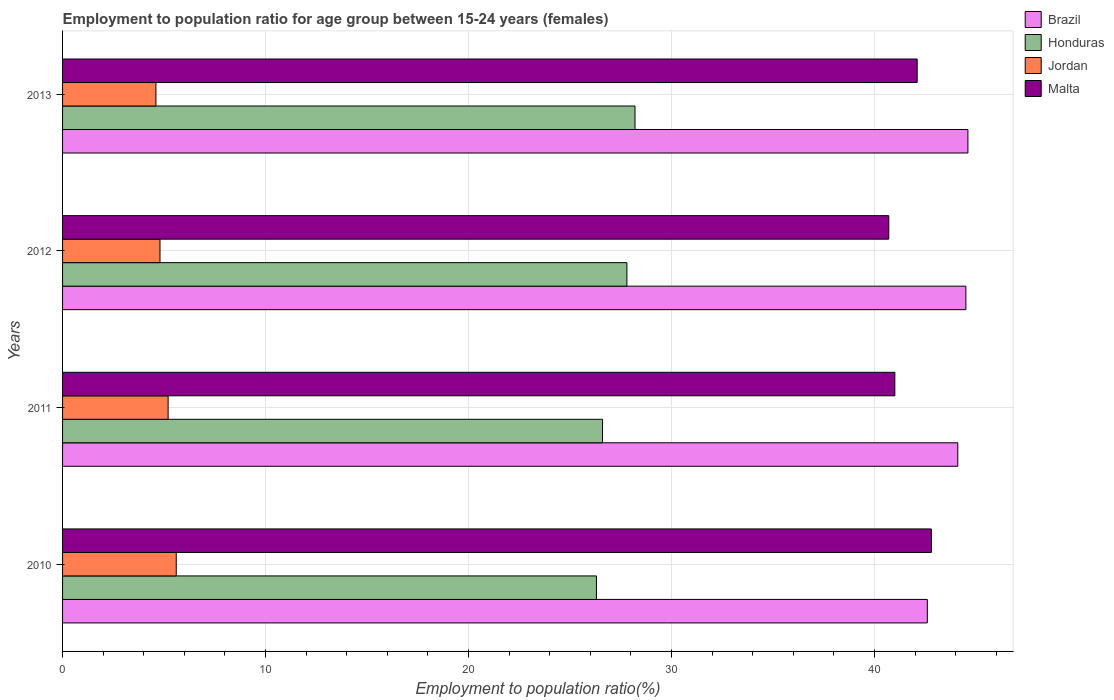How many different coloured bars are there?
Offer a terse response. 4. How many bars are there on the 1st tick from the top?
Ensure brevity in your answer.  4. What is the employment to population ratio in Malta in 2010?
Make the answer very short. 42.8. Across all years, what is the maximum employment to population ratio in Brazil?
Offer a very short reply. 44.6. Across all years, what is the minimum employment to population ratio in Honduras?
Your response must be concise. 26.3. In which year was the employment to population ratio in Honduras maximum?
Make the answer very short. 2013. In which year was the employment to population ratio in Malta minimum?
Provide a short and direct response. 2012. What is the total employment to population ratio in Jordan in the graph?
Give a very brief answer. 20.2. What is the difference between the employment to population ratio in Malta in 2010 and that in 2013?
Make the answer very short. 0.7. What is the difference between the employment to population ratio in Brazil in 2011 and the employment to population ratio in Honduras in 2012?
Provide a succinct answer. 16.3. What is the average employment to population ratio in Honduras per year?
Provide a succinct answer. 27.22. In the year 2010, what is the difference between the employment to population ratio in Brazil and employment to population ratio in Malta?
Your response must be concise. -0.2. In how many years, is the employment to population ratio in Brazil greater than 20 %?
Keep it short and to the point. 4. What is the ratio of the employment to population ratio in Brazil in 2010 to that in 2011?
Give a very brief answer. 0.97. What is the difference between the highest and the second highest employment to population ratio in Brazil?
Ensure brevity in your answer.  0.1. What is the difference between the highest and the lowest employment to population ratio in Malta?
Offer a terse response. 2.1. In how many years, is the employment to population ratio in Honduras greater than the average employment to population ratio in Honduras taken over all years?
Your response must be concise. 2. Is the sum of the employment to population ratio in Malta in 2011 and 2012 greater than the maximum employment to population ratio in Jordan across all years?
Your answer should be compact. Yes. Is it the case that in every year, the sum of the employment to population ratio in Malta and employment to population ratio in Honduras is greater than the sum of employment to population ratio in Jordan and employment to population ratio in Brazil?
Ensure brevity in your answer.  No. What does the 2nd bar from the top in 2013 represents?
Keep it short and to the point. Jordan. What does the 2nd bar from the bottom in 2013 represents?
Your answer should be compact. Honduras. What is the difference between two consecutive major ticks on the X-axis?
Provide a succinct answer. 10. Does the graph contain any zero values?
Offer a terse response. No. Where does the legend appear in the graph?
Your response must be concise. Top right. What is the title of the graph?
Give a very brief answer. Employment to population ratio for age group between 15-24 years (females). What is the label or title of the X-axis?
Provide a short and direct response. Employment to population ratio(%). What is the label or title of the Y-axis?
Offer a very short reply. Years. What is the Employment to population ratio(%) of Brazil in 2010?
Your answer should be very brief. 42.6. What is the Employment to population ratio(%) of Honduras in 2010?
Your answer should be compact. 26.3. What is the Employment to population ratio(%) of Jordan in 2010?
Your response must be concise. 5.6. What is the Employment to population ratio(%) of Malta in 2010?
Make the answer very short. 42.8. What is the Employment to population ratio(%) in Brazil in 2011?
Provide a succinct answer. 44.1. What is the Employment to population ratio(%) in Honduras in 2011?
Your answer should be compact. 26.6. What is the Employment to population ratio(%) in Jordan in 2011?
Provide a succinct answer. 5.2. What is the Employment to population ratio(%) of Brazil in 2012?
Provide a succinct answer. 44.5. What is the Employment to population ratio(%) of Honduras in 2012?
Your answer should be very brief. 27.8. What is the Employment to population ratio(%) in Jordan in 2012?
Make the answer very short. 4.8. What is the Employment to population ratio(%) in Malta in 2012?
Offer a terse response. 40.7. What is the Employment to population ratio(%) of Brazil in 2013?
Provide a succinct answer. 44.6. What is the Employment to population ratio(%) of Honduras in 2013?
Offer a very short reply. 28.2. What is the Employment to population ratio(%) in Jordan in 2013?
Your answer should be very brief. 4.6. What is the Employment to population ratio(%) in Malta in 2013?
Give a very brief answer. 42.1. Across all years, what is the maximum Employment to population ratio(%) in Brazil?
Offer a very short reply. 44.6. Across all years, what is the maximum Employment to population ratio(%) of Honduras?
Give a very brief answer. 28.2. Across all years, what is the maximum Employment to population ratio(%) in Jordan?
Your answer should be very brief. 5.6. Across all years, what is the maximum Employment to population ratio(%) of Malta?
Your answer should be compact. 42.8. Across all years, what is the minimum Employment to population ratio(%) of Brazil?
Your answer should be very brief. 42.6. Across all years, what is the minimum Employment to population ratio(%) of Honduras?
Provide a succinct answer. 26.3. Across all years, what is the minimum Employment to population ratio(%) in Jordan?
Provide a short and direct response. 4.6. Across all years, what is the minimum Employment to population ratio(%) in Malta?
Offer a very short reply. 40.7. What is the total Employment to population ratio(%) of Brazil in the graph?
Ensure brevity in your answer.  175.8. What is the total Employment to population ratio(%) of Honduras in the graph?
Provide a succinct answer. 108.9. What is the total Employment to population ratio(%) in Jordan in the graph?
Keep it short and to the point. 20.2. What is the total Employment to population ratio(%) in Malta in the graph?
Provide a short and direct response. 166.6. What is the difference between the Employment to population ratio(%) of Honduras in 2010 and that in 2011?
Provide a short and direct response. -0.3. What is the difference between the Employment to population ratio(%) in Jordan in 2010 and that in 2011?
Your answer should be compact. 0.4. What is the difference between the Employment to population ratio(%) in Malta in 2010 and that in 2011?
Your response must be concise. 1.8. What is the difference between the Employment to population ratio(%) in Brazil in 2010 and that in 2012?
Offer a terse response. -1.9. What is the difference between the Employment to population ratio(%) in Honduras in 2010 and that in 2012?
Your answer should be compact. -1.5. What is the difference between the Employment to population ratio(%) in Jordan in 2010 and that in 2012?
Make the answer very short. 0.8. What is the difference between the Employment to population ratio(%) in Malta in 2010 and that in 2012?
Make the answer very short. 2.1. What is the difference between the Employment to population ratio(%) in Honduras in 2010 and that in 2013?
Offer a very short reply. -1.9. What is the difference between the Employment to population ratio(%) in Malta in 2010 and that in 2013?
Your answer should be very brief. 0.7. What is the difference between the Employment to population ratio(%) of Malta in 2011 and that in 2012?
Give a very brief answer. 0.3. What is the difference between the Employment to population ratio(%) in Brazil in 2011 and that in 2013?
Offer a very short reply. -0.5. What is the difference between the Employment to population ratio(%) of Malta in 2011 and that in 2013?
Make the answer very short. -1.1. What is the difference between the Employment to population ratio(%) of Brazil in 2012 and that in 2013?
Your response must be concise. -0.1. What is the difference between the Employment to population ratio(%) of Honduras in 2012 and that in 2013?
Ensure brevity in your answer.  -0.4. What is the difference between the Employment to population ratio(%) of Jordan in 2012 and that in 2013?
Make the answer very short. 0.2. What is the difference between the Employment to population ratio(%) of Brazil in 2010 and the Employment to population ratio(%) of Honduras in 2011?
Your answer should be very brief. 16. What is the difference between the Employment to population ratio(%) of Brazil in 2010 and the Employment to population ratio(%) of Jordan in 2011?
Give a very brief answer. 37.4. What is the difference between the Employment to population ratio(%) of Brazil in 2010 and the Employment to population ratio(%) of Malta in 2011?
Give a very brief answer. 1.6. What is the difference between the Employment to population ratio(%) in Honduras in 2010 and the Employment to population ratio(%) in Jordan in 2011?
Your answer should be compact. 21.1. What is the difference between the Employment to population ratio(%) in Honduras in 2010 and the Employment to population ratio(%) in Malta in 2011?
Your answer should be very brief. -14.7. What is the difference between the Employment to population ratio(%) in Jordan in 2010 and the Employment to population ratio(%) in Malta in 2011?
Make the answer very short. -35.4. What is the difference between the Employment to population ratio(%) in Brazil in 2010 and the Employment to population ratio(%) in Honduras in 2012?
Your answer should be compact. 14.8. What is the difference between the Employment to population ratio(%) of Brazil in 2010 and the Employment to population ratio(%) of Jordan in 2012?
Provide a short and direct response. 37.8. What is the difference between the Employment to population ratio(%) in Honduras in 2010 and the Employment to population ratio(%) in Jordan in 2012?
Provide a short and direct response. 21.5. What is the difference between the Employment to population ratio(%) in Honduras in 2010 and the Employment to population ratio(%) in Malta in 2012?
Keep it short and to the point. -14.4. What is the difference between the Employment to population ratio(%) in Jordan in 2010 and the Employment to population ratio(%) in Malta in 2012?
Your response must be concise. -35.1. What is the difference between the Employment to population ratio(%) of Brazil in 2010 and the Employment to population ratio(%) of Honduras in 2013?
Ensure brevity in your answer.  14.4. What is the difference between the Employment to population ratio(%) in Brazil in 2010 and the Employment to population ratio(%) in Jordan in 2013?
Ensure brevity in your answer.  38. What is the difference between the Employment to population ratio(%) of Brazil in 2010 and the Employment to population ratio(%) of Malta in 2013?
Your answer should be very brief. 0.5. What is the difference between the Employment to population ratio(%) of Honduras in 2010 and the Employment to population ratio(%) of Jordan in 2013?
Your answer should be compact. 21.7. What is the difference between the Employment to population ratio(%) of Honduras in 2010 and the Employment to population ratio(%) of Malta in 2013?
Provide a succinct answer. -15.8. What is the difference between the Employment to population ratio(%) of Jordan in 2010 and the Employment to population ratio(%) of Malta in 2013?
Offer a terse response. -36.5. What is the difference between the Employment to population ratio(%) in Brazil in 2011 and the Employment to population ratio(%) in Honduras in 2012?
Keep it short and to the point. 16.3. What is the difference between the Employment to population ratio(%) of Brazil in 2011 and the Employment to population ratio(%) of Jordan in 2012?
Ensure brevity in your answer.  39.3. What is the difference between the Employment to population ratio(%) of Honduras in 2011 and the Employment to population ratio(%) of Jordan in 2012?
Keep it short and to the point. 21.8. What is the difference between the Employment to population ratio(%) of Honduras in 2011 and the Employment to population ratio(%) of Malta in 2012?
Make the answer very short. -14.1. What is the difference between the Employment to population ratio(%) of Jordan in 2011 and the Employment to population ratio(%) of Malta in 2012?
Your answer should be compact. -35.5. What is the difference between the Employment to population ratio(%) in Brazil in 2011 and the Employment to population ratio(%) in Jordan in 2013?
Keep it short and to the point. 39.5. What is the difference between the Employment to population ratio(%) in Brazil in 2011 and the Employment to population ratio(%) in Malta in 2013?
Provide a succinct answer. 2. What is the difference between the Employment to population ratio(%) in Honduras in 2011 and the Employment to population ratio(%) in Jordan in 2013?
Your response must be concise. 22. What is the difference between the Employment to population ratio(%) of Honduras in 2011 and the Employment to population ratio(%) of Malta in 2013?
Provide a short and direct response. -15.5. What is the difference between the Employment to population ratio(%) of Jordan in 2011 and the Employment to population ratio(%) of Malta in 2013?
Give a very brief answer. -36.9. What is the difference between the Employment to population ratio(%) of Brazil in 2012 and the Employment to population ratio(%) of Jordan in 2013?
Provide a succinct answer. 39.9. What is the difference between the Employment to population ratio(%) of Honduras in 2012 and the Employment to population ratio(%) of Jordan in 2013?
Make the answer very short. 23.2. What is the difference between the Employment to population ratio(%) in Honduras in 2012 and the Employment to population ratio(%) in Malta in 2013?
Keep it short and to the point. -14.3. What is the difference between the Employment to population ratio(%) in Jordan in 2012 and the Employment to population ratio(%) in Malta in 2013?
Your response must be concise. -37.3. What is the average Employment to population ratio(%) in Brazil per year?
Offer a terse response. 43.95. What is the average Employment to population ratio(%) in Honduras per year?
Your response must be concise. 27.23. What is the average Employment to population ratio(%) in Jordan per year?
Make the answer very short. 5.05. What is the average Employment to population ratio(%) of Malta per year?
Provide a short and direct response. 41.65. In the year 2010, what is the difference between the Employment to population ratio(%) in Brazil and Employment to population ratio(%) in Honduras?
Your response must be concise. 16.3. In the year 2010, what is the difference between the Employment to population ratio(%) in Brazil and Employment to population ratio(%) in Jordan?
Provide a succinct answer. 37. In the year 2010, what is the difference between the Employment to population ratio(%) in Honduras and Employment to population ratio(%) in Jordan?
Provide a succinct answer. 20.7. In the year 2010, what is the difference between the Employment to population ratio(%) in Honduras and Employment to population ratio(%) in Malta?
Offer a terse response. -16.5. In the year 2010, what is the difference between the Employment to population ratio(%) in Jordan and Employment to population ratio(%) in Malta?
Provide a short and direct response. -37.2. In the year 2011, what is the difference between the Employment to population ratio(%) in Brazil and Employment to population ratio(%) in Jordan?
Keep it short and to the point. 38.9. In the year 2011, what is the difference between the Employment to population ratio(%) in Brazil and Employment to population ratio(%) in Malta?
Make the answer very short. 3.1. In the year 2011, what is the difference between the Employment to population ratio(%) in Honduras and Employment to population ratio(%) in Jordan?
Offer a terse response. 21.4. In the year 2011, what is the difference between the Employment to population ratio(%) in Honduras and Employment to population ratio(%) in Malta?
Ensure brevity in your answer.  -14.4. In the year 2011, what is the difference between the Employment to population ratio(%) in Jordan and Employment to population ratio(%) in Malta?
Offer a very short reply. -35.8. In the year 2012, what is the difference between the Employment to population ratio(%) of Brazil and Employment to population ratio(%) of Jordan?
Keep it short and to the point. 39.7. In the year 2012, what is the difference between the Employment to population ratio(%) of Honduras and Employment to population ratio(%) of Malta?
Give a very brief answer. -12.9. In the year 2012, what is the difference between the Employment to population ratio(%) in Jordan and Employment to population ratio(%) in Malta?
Your answer should be very brief. -35.9. In the year 2013, what is the difference between the Employment to population ratio(%) in Brazil and Employment to population ratio(%) in Honduras?
Your response must be concise. 16.4. In the year 2013, what is the difference between the Employment to population ratio(%) in Brazil and Employment to population ratio(%) in Jordan?
Your response must be concise. 40. In the year 2013, what is the difference between the Employment to population ratio(%) in Brazil and Employment to population ratio(%) in Malta?
Provide a short and direct response. 2.5. In the year 2013, what is the difference between the Employment to population ratio(%) of Honduras and Employment to population ratio(%) of Jordan?
Make the answer very short. 23.6. In the year 2013, what is the difference between the Employment to population ratio(%) of Honduras and Employment to population ratio(%) of Malta?
Offer a very short reply. -13.9. In the year 2013, what is the difference between the Employment to population ratio(%) of Jordan and Employment to population ratio(%) of Malta?
Offer a terse response. -37.5. What is the ratio of the Employment to population ratio(%) of Honduras in 2010 to that in 2011?
Provide a short and direct response. 0.99. What is the ratio of the Employment to population ratio(%) in Jordan in 2010 to that in 2011?
Your response must be concise. 1.08. What is the ratio of the Employment to population ratio(%) of Malta in 2010 to that in 2011?
Your answer should be compact. 1.04. What is the ratio of the Employment to population ratio(%) in Brazil in 2010 to that in 2012?
Provide a short and direct response. 0.96. What is the ratio of the Employment to population ratio(%) in Honduras in 2010 to that in 2012?
Your response must be concise. 0.95. What is the ratio of the Employment to population ratio(%) of Jordan in 2010 to that in 2012?
Your answer should be very brief. 1.17. What is the ratio of the Employment to population ratio(%) in Malta in 2010 to that in 2012?
Your answer should be compact. 1.05. What is the ratio of the Employment to population ratio(%) in Brazil in 2010 to that in 2013?
Your answer should be very brief. 0.96. What is the ratio of the Employment to population ratio(%) in Honduras in 2010 to that in 2013?
Give a very brief answer. 0.93. What is the ratio of the Employment to population ratio(%) in Jordan in 2010 to that in 2013?
Make the answer very short. 1.22. What is the ratio of the Employment to population ratio(%) in Malta in 2010 to that in 2013?
Give a very brief answer. 1.02. What is the ratio of the Employment to population ratio(%) of Honduras in 2011 to that in 2012?
Give a very brief answer. 0.96. What is the ratio of the Employment to population ratio(%) of Malta in 2011 to that in 2012?
Your answer should be compact. 1.01. What is the ratio of the Employment to population ratio(%) in Honduras in 2011 to that in 2013?
Your answer should be very brief. 0.94. What is the ratio of the Employment to population ratio(%) in Jordan in 2011 to that in 2013?
Provide a succinct answer. 1.13. What is the ratio of the Employment to population ratio(%) in Malta in 2011 to that in 2013?
Provide a short and direct response. 0.97. What is the ratio of the Employment to population ratio(%) in Brazil in 2012 to that in 2013?
Your response must be concise. 1. What is the ratio of the Employment to population ratio(%) of Honduras in 2012 to that in 2013?
Keep it short and to the point. 0.99. What is the ratio of the Employment to population ratio(%) in Jordan in 2012 to that in 2013?
Keep it short and to the point. 1.04. What is the ratio of the Employment to population ratio(%) of Malta in 2012 to that in 2013?
Offer a terse response. 0.97. What is the difference between the highest and the second highest Employment to population ratio(%) of Brazil?
Provide a short and direct response. 0.1. What is the difference between the highest and the second highest Employment to population ratio(%) in Jordan?
Give a very brief answer. 0.4. What is the difference between the highest and the second highest Employment to population ratio(%) of Malta?
Your answer should be compact. 0.7. What is the difference between the highest and the lowest Employment to population ratio(%) of Brazil?
Keep it short and to the point. 2. What is the difference between the highest and the lowest Employment to population ratio(%) in Malta?
Make the answer very short. 2.1. 